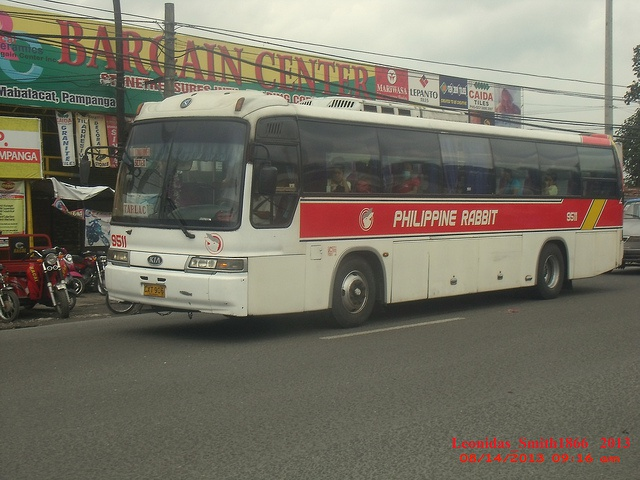Describe the objects in this image and their specific colors. I can see bus in lightgray, gray, darkgray, black, and brown tones, motorcycle in lightgray, black, gray, and maroon tones, motorcycle in lightgray, black, gray, maroon, and darkgray tones, car in lightgray, gray, darkgray, and black tones, and motorcycle in lightgray, black, maroon, and gray tones in this image. 